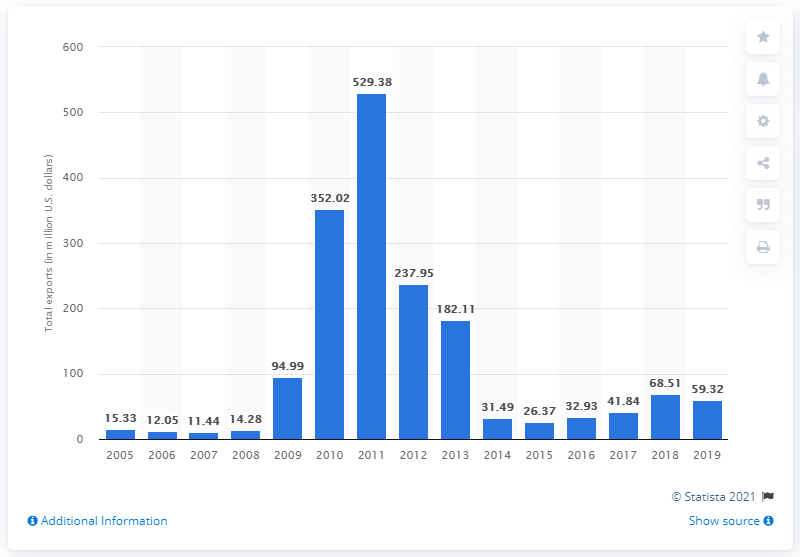List a handful of essential elements in this visual. In 2019, the total value of merchandise exported to China from the United States was 59.32 billion dollars. 